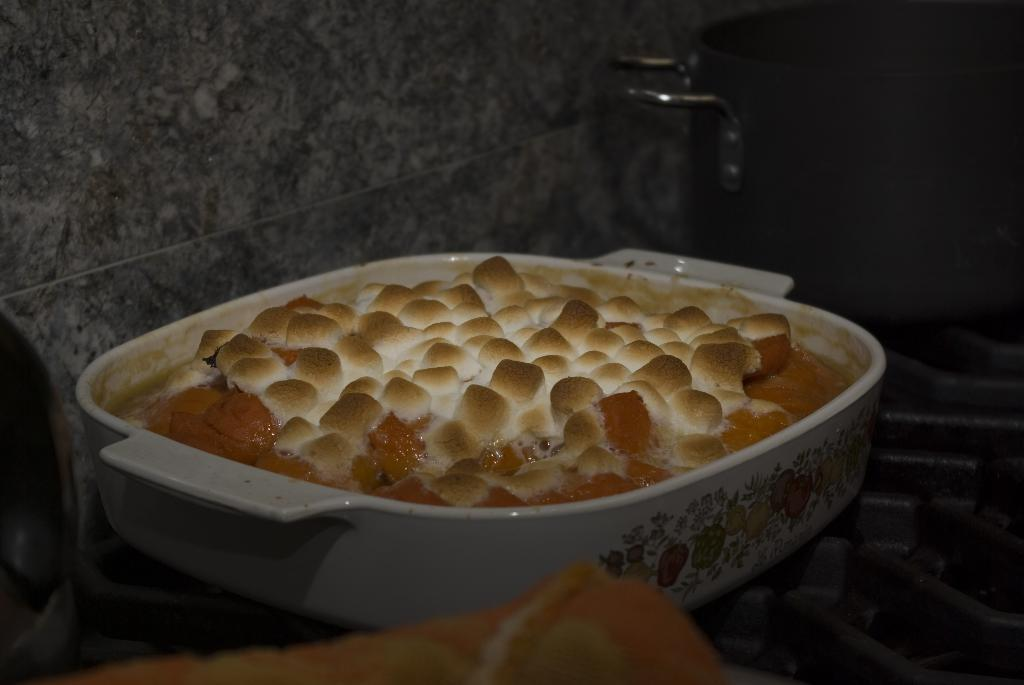What type of food items can be seen in the image? There are food items in a bowl in the image. Can you describe any other objects visible in the image? There are a few objects visible at the bottom of the picture. What kind of kitchen item is present in the image? A kitchen vessel is present in the image. What is located on the left side of the image? There is a wall on the left side of the image. What type of agreement is being discussed in the image? There is no discussion or agreement present in the image; it features food items in a bowl, objects at the bottom of the picture, a kitchen vessel, and a wall on the left side. How does the health of the food items in the image affect the thunder outside? There is no mention of health or thunder in the image; it only shows food items in a bowl, objects at the bottom of the picture, a kitchen vessel, and a wall on the left side. 